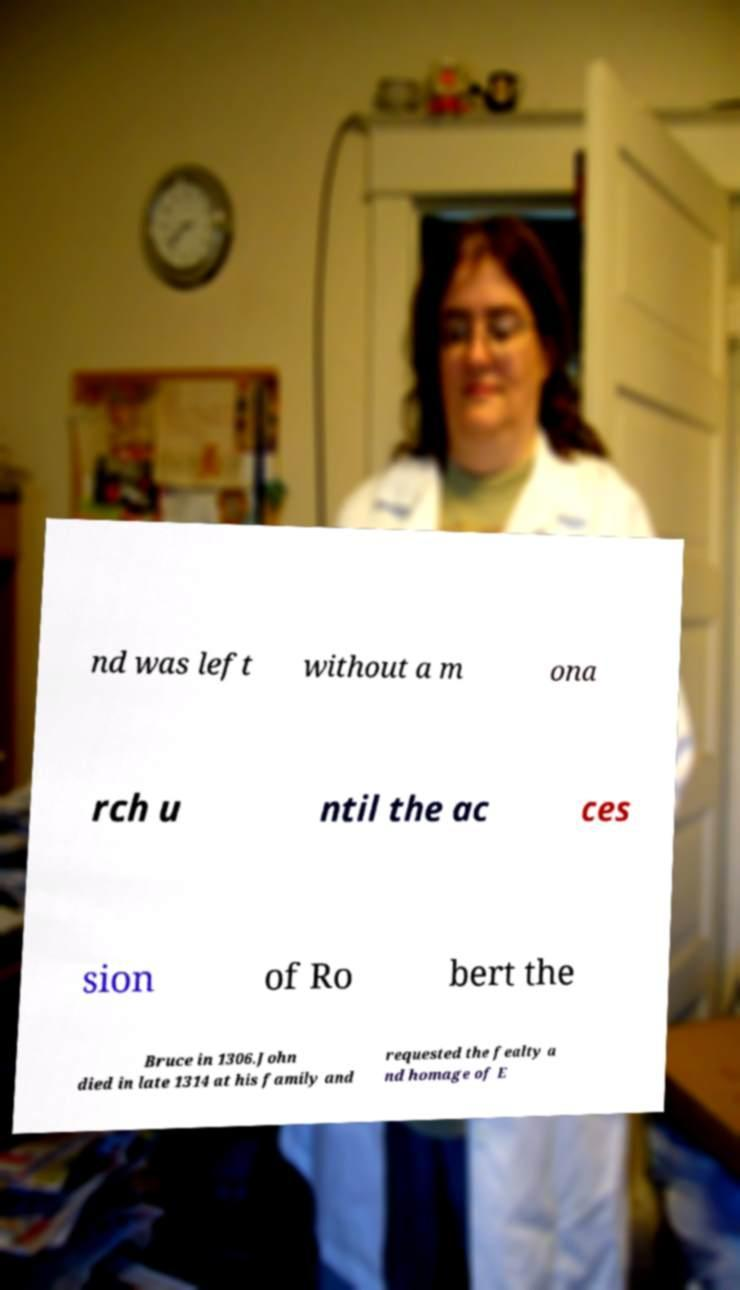Could you assist in decoding the text presented in this image and type it out clearly? nd was left without a m ona rch u ntil the ac ces sion of Ro bert the Bruce in 1306.John died in late 1314 at his family and requested the fealty a nd homage of E 